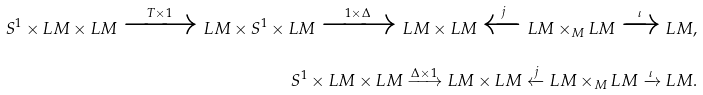<formula> <loc_0><loc_0><loc_500><loc_500>S ^ { 1 } \times L M \times L M \xrightarrow { T \times 1 } L M \times S ^ { 1 } \times L M \xrightarrow { 1 \times \Delta } L M \times L M \xleftarrow { j } L M \times _ { M } L M \xrightarrow { \iota } L M , \\ S ^ { 1 } \times L M \times L M \xrightarrow { \Delta \times 1 } L M \times L M \xleftarrow { j } L M \times _ { M } L M \xrightarrow { \iota } L M .</formula> 